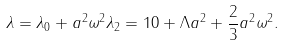Convert formula to latex. <formula><loc_0><loc_0><loc_500><loc_500>\lambda = \lambda _ { 0 } + a ^ { 2 } \omega ^ { 2 } \lambda _ { 2 } = 1 0 + \Lambda a ^ { 2 } + \frac { 2 } { 3 } a ^ { 2 } \omega ^ { 2 } .</formula> 